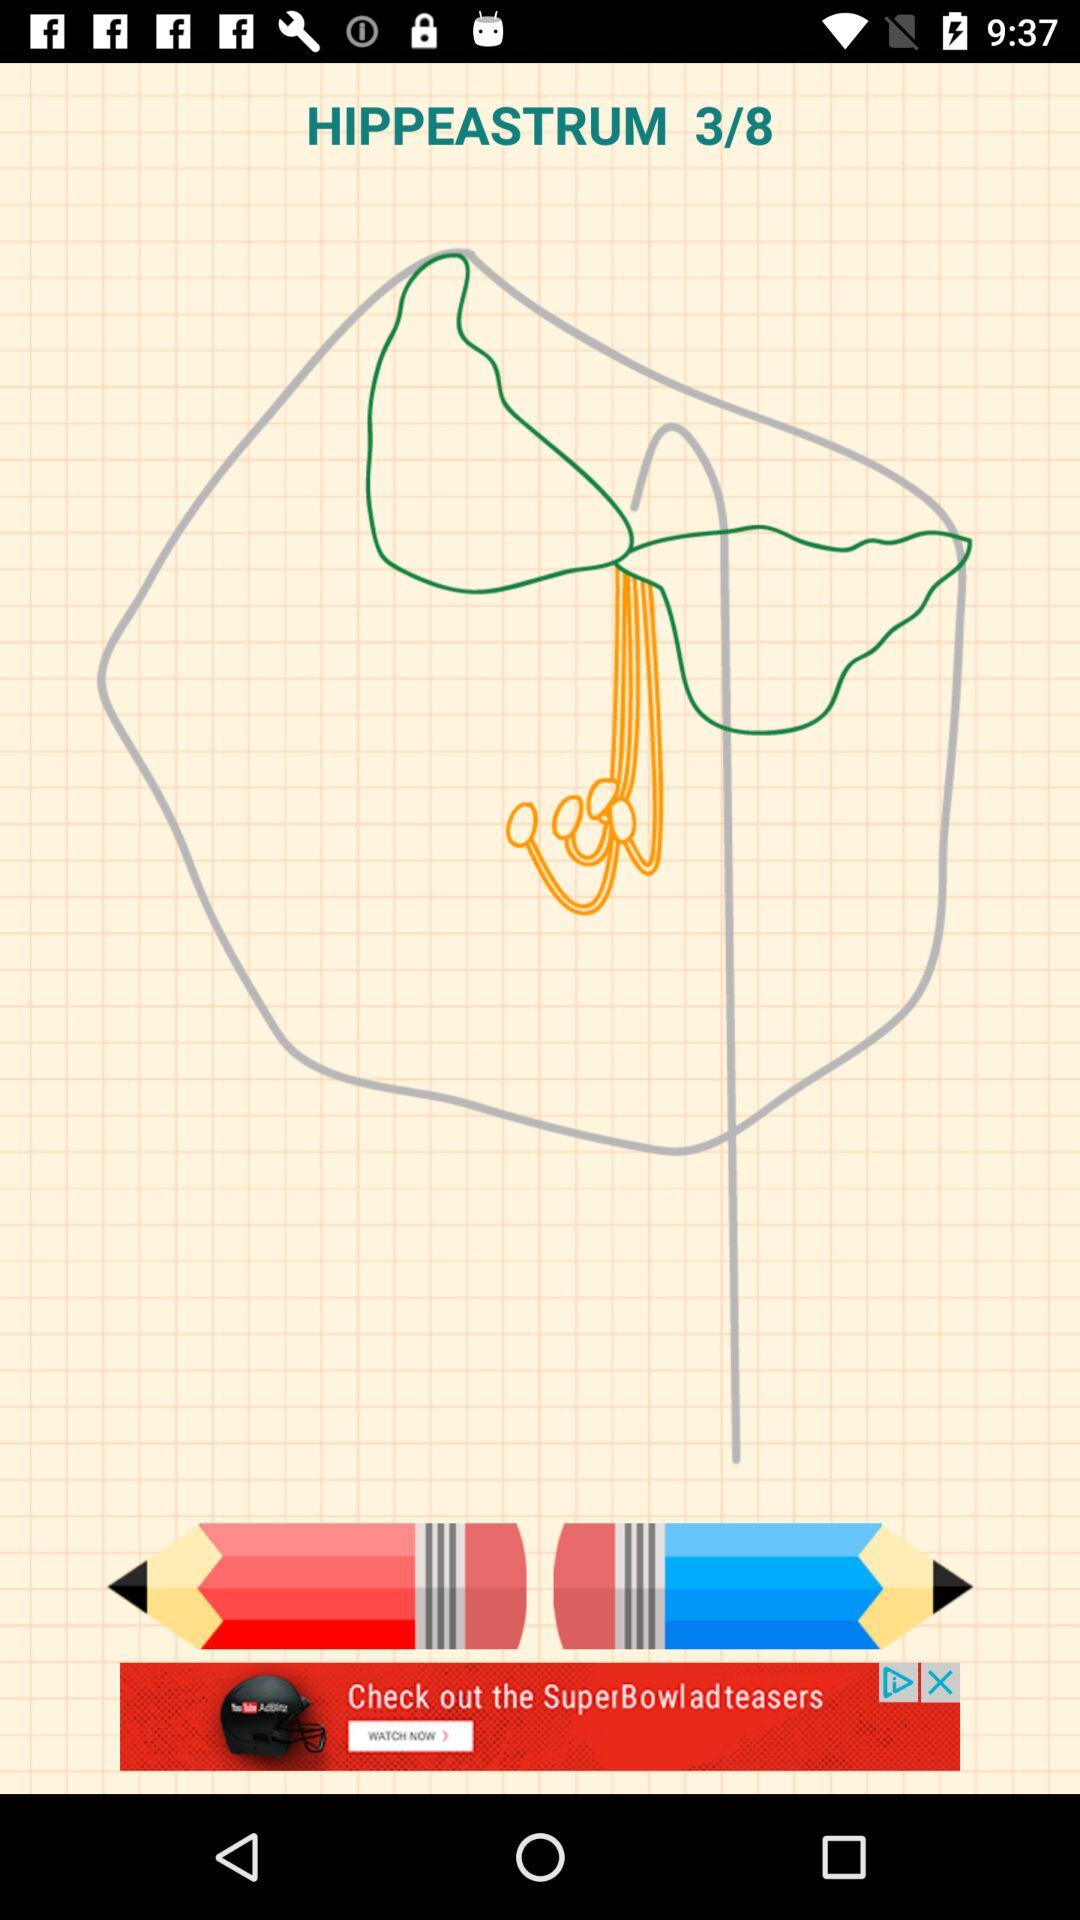What is the total number of steps? The total number of steps is 8. 